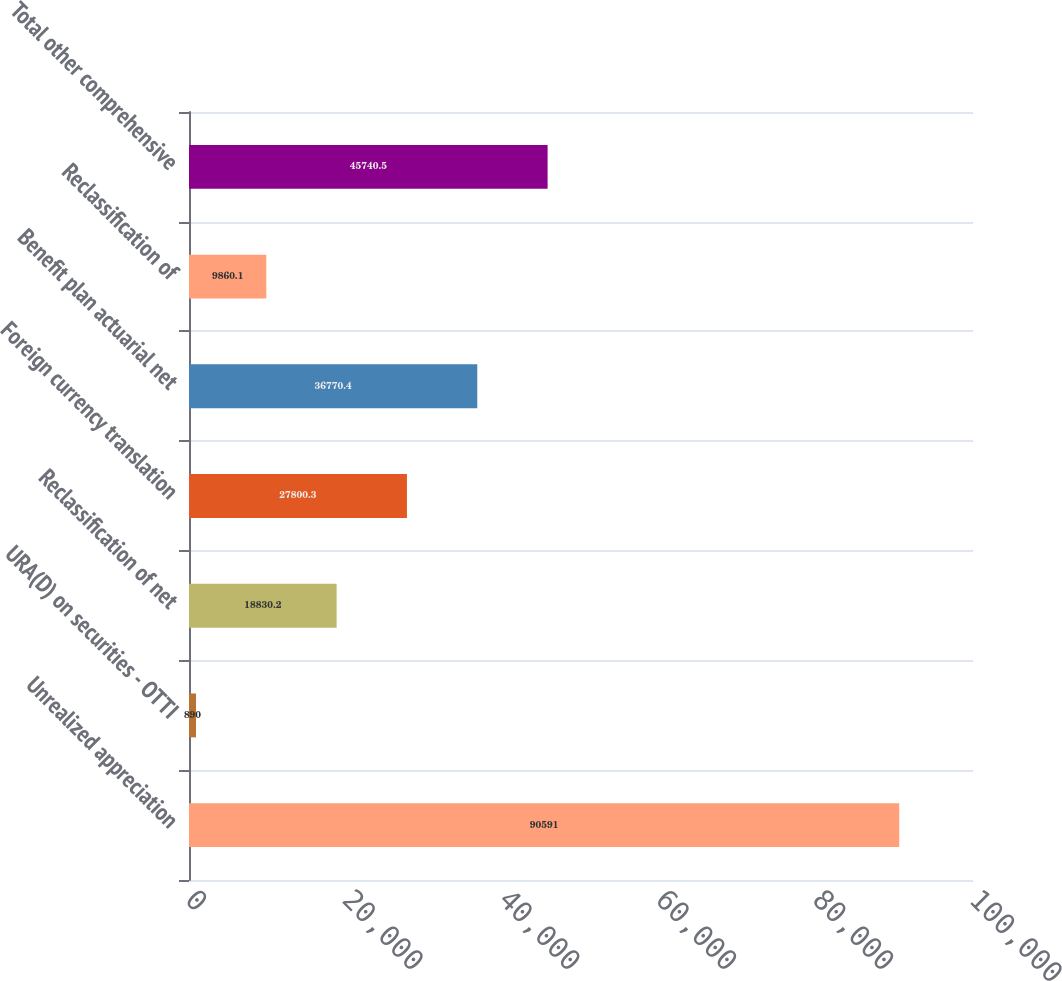Convert chart to OTSL. <chart><loc_0><loc_0><loc_500><loc_500><bar_chart><fcel>Unrealized appreciation<fcel>URA(D) on securities - OTTI<fcel>Reclassification of net<fcel>Foreign currency translation<fcel>Benefit plan actuarial net<fcel>Reclassification of<fcel>Total other comprehensive<nl><fcel>90591<fcel>890<fcel>18830.2<fcel>27800.3<fcel>36770.4<fcel>9860.1<fcel>45740.5<nl></chart> 